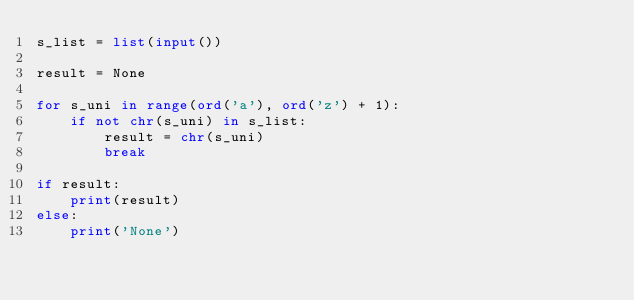<code> <loc_0><loc_0><loc_500><loc_500><_Python_>s_list = list(input())

result = None

for s_uni in range(ord('a'), ord('z') + 1):
    if not chr(s_uni) in s_list:
        result = chr(s_uni)
        break

if result:
    print(result)
else:
    print('None')
</code> 